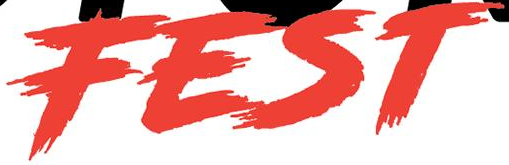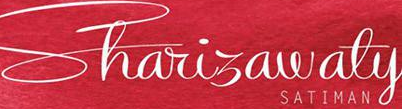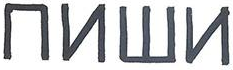Read the text content from these images in order, separated by a semicolon. FEST; Shariɜawaty; ##W# 